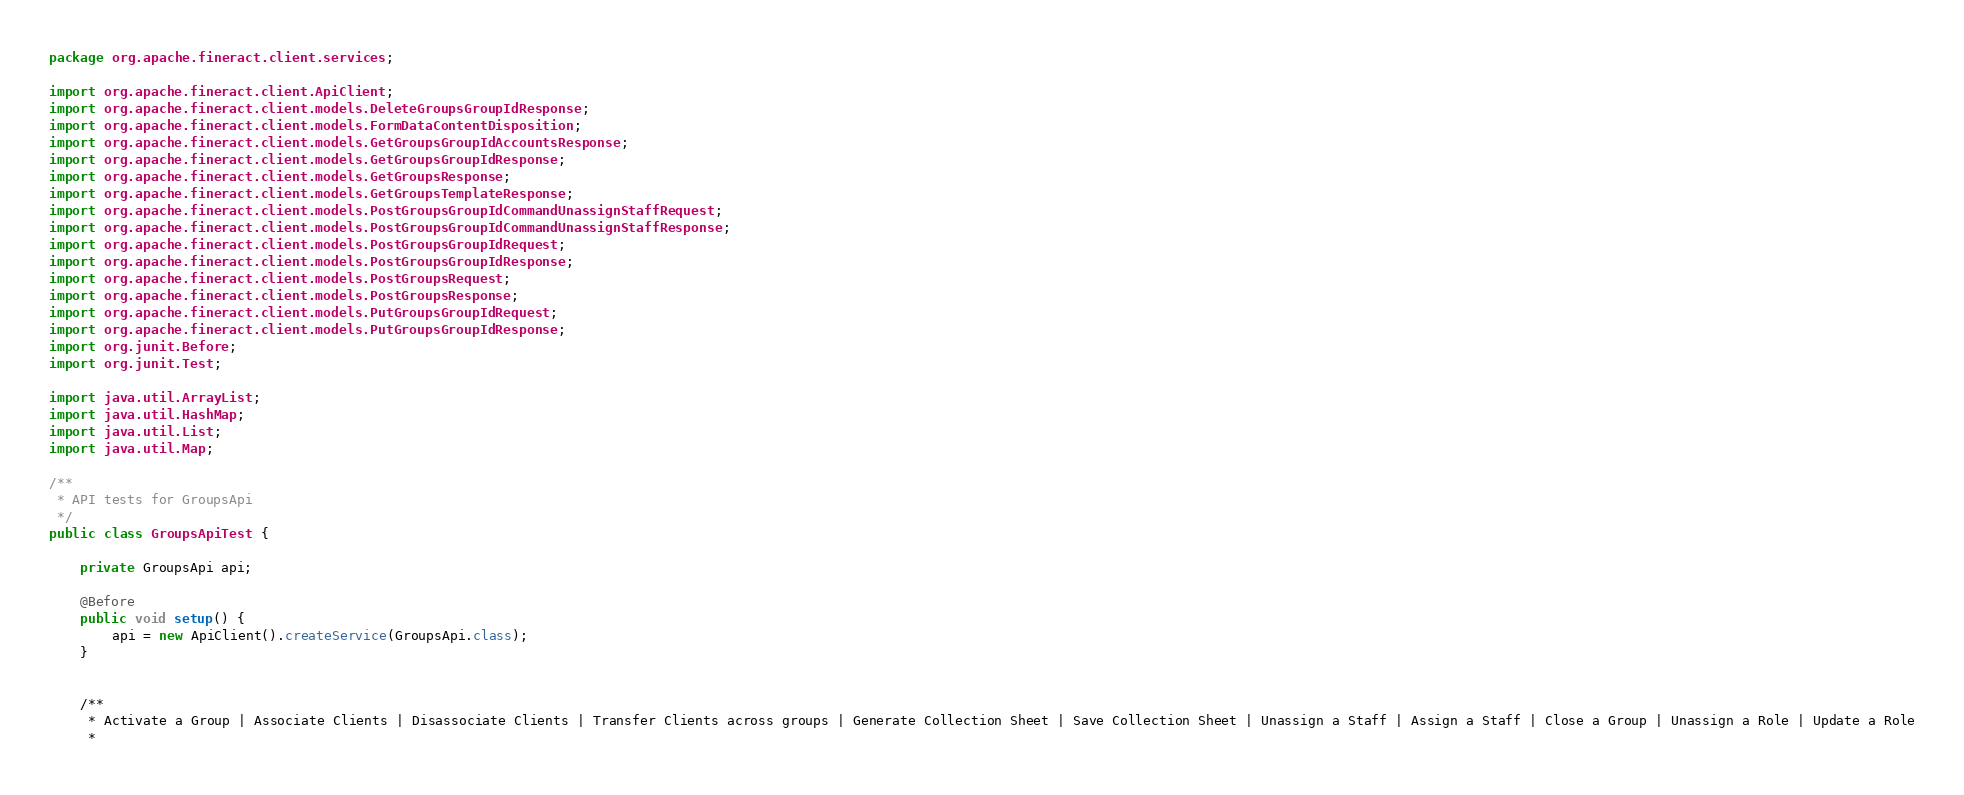<code> <loc_0><loc_0><loc_500><loc_500><_Java_>package org.apache.fineract.client.services;

import org.apache.fineract.client.ApiClient;
import org.apache.fineract.client.models.DeleteGroupsGroupIdResponse;
import org.apache.fineract.client.models.FormDataContentDisposition;
import org.apache.fineract.client.models.GetGroupsGroupIdAccountsResponse;
import org.apache.fineract.client.models.GetGroupsGroupIdResponse;
import org.apache.fineract.client.models.GetGroupsResponse;
import org.apache.fineract.client.models.GetGroupsTemplateResponse;
import org.apache.fineract.client.models.PostGroupsGroupIdCommandUnassignStaffRequest;
import org.apache.fineract.client.models.PostGroupsGroupIdCommandUnassignStaffResponse;
import org.apache.fineract.client.models.PostGroupsGroupIdRequest;
import org.apache.fineract.client.models.PostGroupsGroupIdResponse;
import org.apache.fineract.client.models.PostGroupsRequest;
import org.apache.fineract.client.models.PostGroupsResponse;
import org.apache.fineract.client.models.PutGroupsGroupIdRequest;
import org.apache.fineract.client.models.PutGroupsGroupIdResponse;
import org.junit.Before;
import org.junit.Test;

import java.util.ArrayList;
import java.util.HashMap;
import java.util.List;
import java.util.Map;

/**
 * API tests for GroupsApi
 */
public class GroupsApiTest {

    private GroupsApi api;

    @Before
    public void setup() {
        api = new ApiClient().createService(GroupsApi.class);
    }


    /**
     * Activate a Group | Associate Clients | Disassociate Clients | Transfer Clients across groups | Generate Collection Sheet | Save Collection Sheet | Unassign a Staff | Assign a Staff | Close a Group | Unassign a Role | Update a Role
     *</code> 